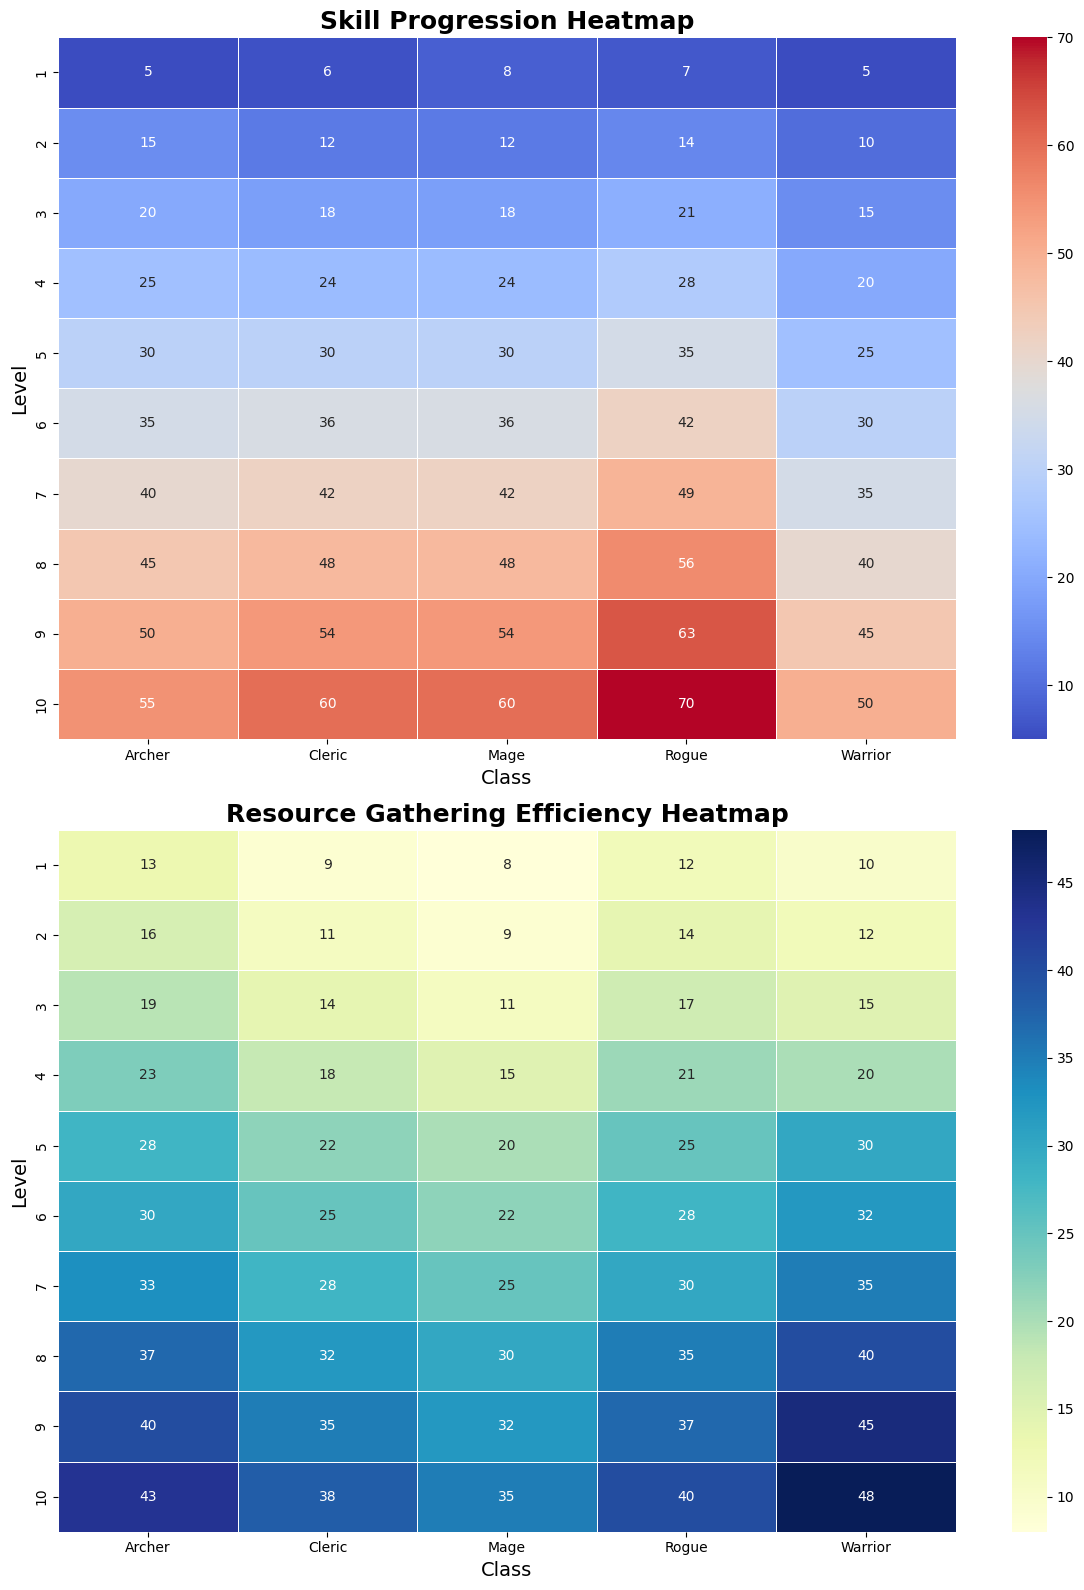What is the highest Resource Gathering Efficiency for a Rogue and at what level? To find the highest Resource Gathering Efficiency for a Rogue, look at the row for “Rogue” in the heatmap titled "Resource Gathering Efficiency Heatmap." Identify the highest numerical value and the corresponding level.
Answer: 40 at level 10 Which class has the lowest Skill Progression at level 3? Look at the row for level 3 in the heatmap titled "Skill Progression Heatmap." Identify the class with the lowest numerical value.
Answer: Warrior Compare the Skill Progression of a Mage at level 5 to an Archer at the same level. Which one is higher and by how much? Locate the values for Mage and Archer at level 5 in the "Skill Progression Heatmap." Compare the numerical values and calculate the difference. Mage: 30, Archer: 30. Difference: 0.
Answer: Equal, difference is 0 At what level does the Cleric first surpass a Skill Progression of 40? In the "Skill Progression Heatmap," find the row for Cleric and identify the smallest level where the value exceeds 40.
Answer: Level 7 Which class shows the most consistent increase (i.e., no drops) in Resource Gathering Efficiency from level 1 to level 10? Examine the "Resource Gathering Efficiency Heatmap,” and check the vertical values for each class from level 1 to 10, identifying which class increments steadily without any decrease.
Answer: Archer What is the average Resource Gathering Efficiency of Warriors from level 1 to level 5? Sum the Resource Gathering Efficiency values for Warrior from level 1 to level 5 and divide by the number of levels. (10 + 12 + 15 + 20 + 30) / 5 = 87 / 5.
Answer: 17.4 Is the color in the Skill Progression Heatmap for level 10 mages more similar to the color in level 10 rogues' or level 10 clerics'? Visually compare the color shading at level 10 for mages, rogues, and clerics in the "Skill Progression Heatmap" to determine the closest match.
Answer: Rogues Which class has a more significant deviation in Resource Gathering Efficiency between the first level and the last level? Subtract the Resource Gathering Efficiency at level 1 from the Resource Gathering Efficiency at level 10 for each class and compare these differences.
Answer: Warrior (48 - 10 = 38) 